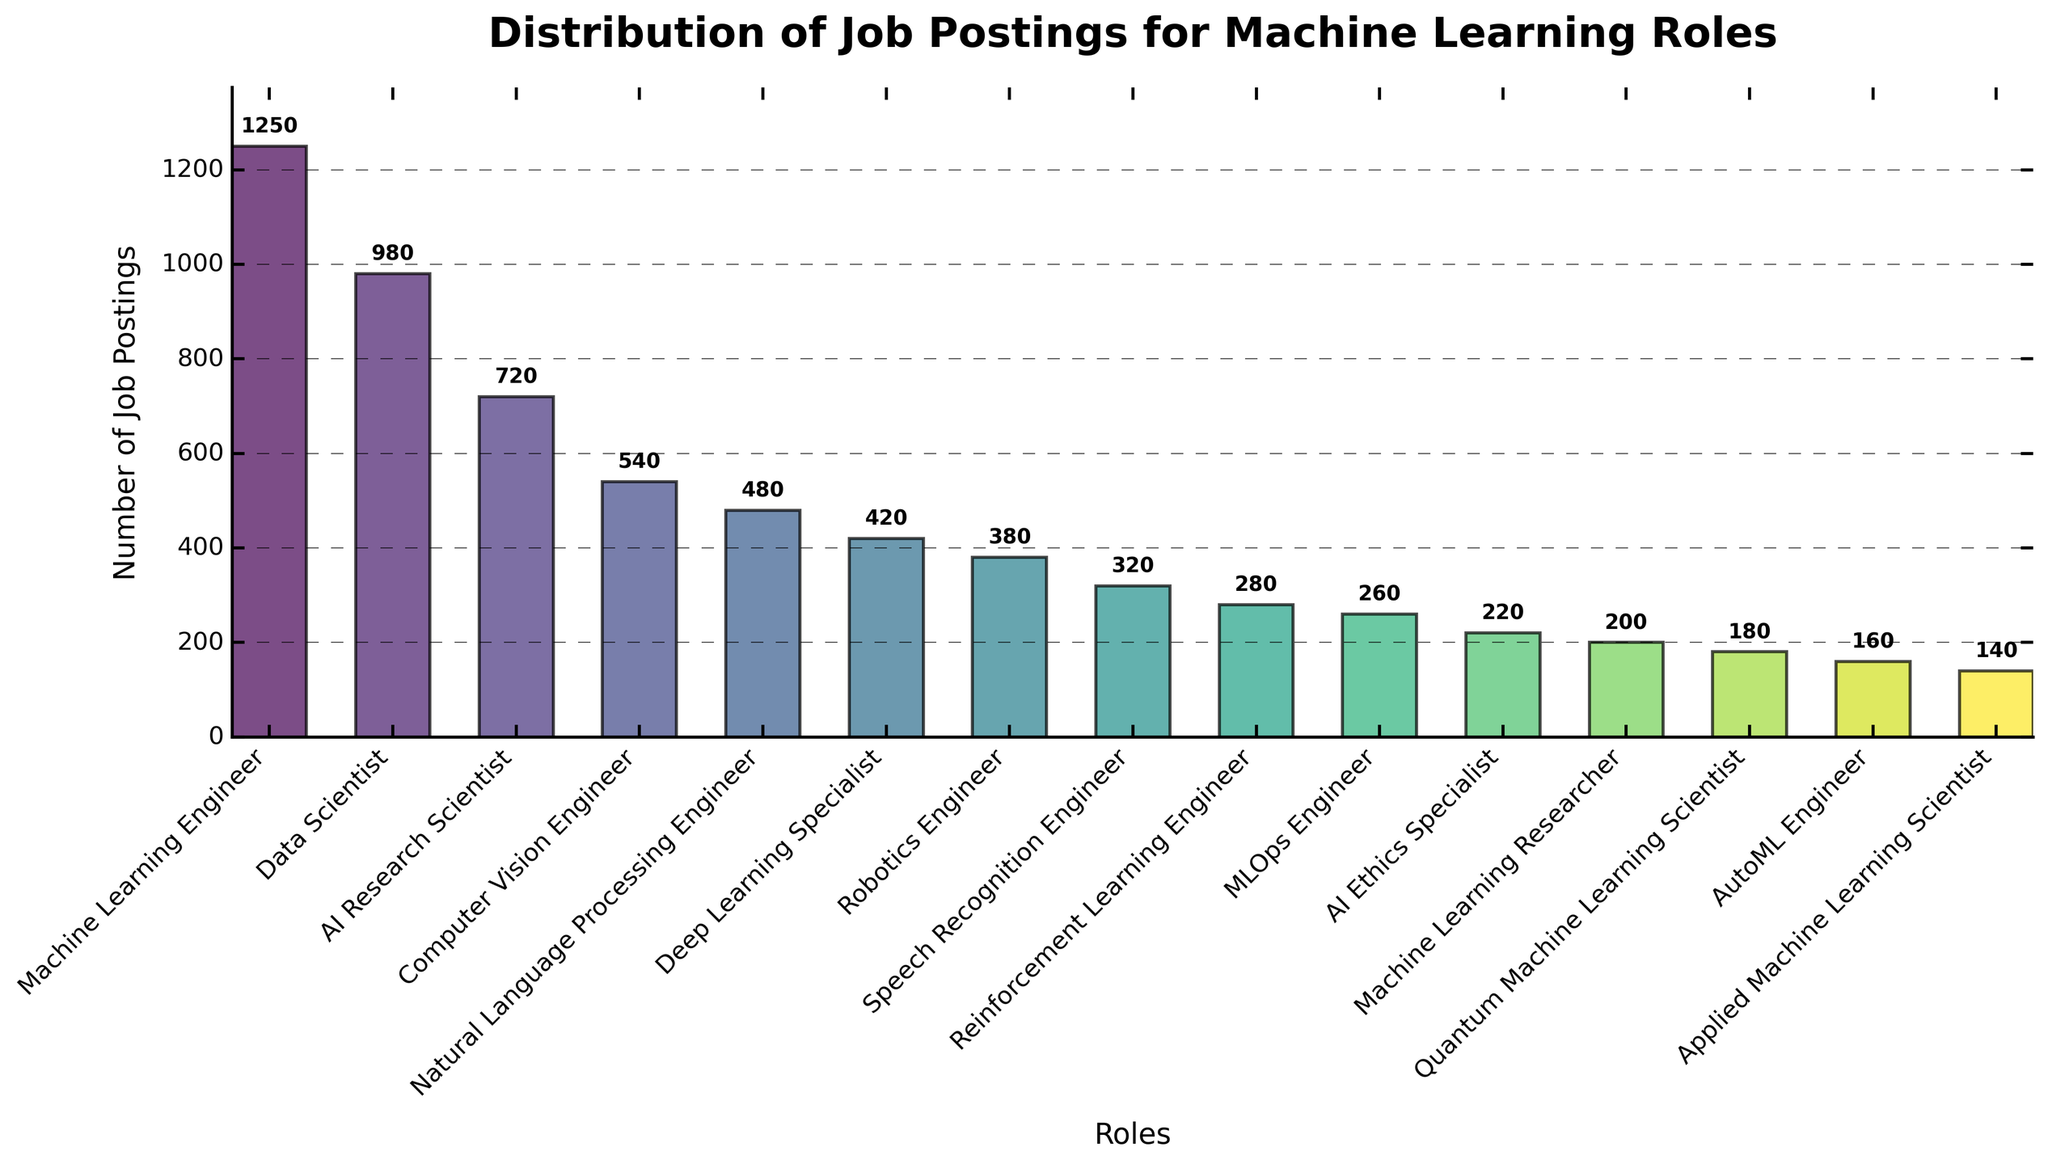How many more job postings are there for Machine Learning Engineers than for Data Scientists? To find the difference in the number of job postings between Machine Learning Engineers and Data Scientists, subtract the number of postings for Data Scientists from those for Machine Learning Engineers: 1250 - 980 = 270
Answer: 270 Which role has the fewest job postings, and how many postings does it have? By looking at the height of the bars, the role with the fewest job postings is Applied Machine Learning Scientist. Its bar is the shortest, representing 140 postings
Answer: Applied Machine Learning Scientist, 140 What's the combined total number of job postings for AI Research Scientist and Natural Language Processing Engineer roles? Add the number of job postings for both roles: 720 (AI Research Scientist) + 480 (Natural Language Processing Engineer) = 1200
Answer: 1200 Which role has fewer job postings: Deep Learning Specialist or MLOps Engineer? By comparing the heights of the bars for Deep Learning Specialist and MLOps Engineer roles, MLOps Engineer has fewer postings: 260 for MLOps Engineer vs. 420 for Deep Learning Specialist
Answer: MLOps Engineer What's the average number of job postings across all the roles? First, sum the number of job postings for all roles and then divide by the number of roles. The sum is 1250 + 980 + 720 + 540 + 480 + 420 + 380 + 320 + 280 + 260 + 220 + 200 + 180 + 160 + 140 = 7530. There are 15 roles, so the average is 7530 / 15 = 502
Answer: 502 Which role has a higher number of job postings, AI Ethics Specialist or Quantum Machine Learning Scientist, and by how much? Compare the heights of the bars for both roles. AI Ethics Specialist has 220 postings, and Quantum Machine Learning Scientist has 180 postings. The difference is 220 - 180 = 40
Answer: AI Ethics Specialist, by 40 What's the ratio of the number of job postings for Machine Learning Engineer to the number of postings for AutoML Engineer? To find the ratio, divide the number of postings for Machine Learning Engineer by the number for AutoML Engineer: 1250 / 160 = 7.8125
Answer: 7.8125 Identify the two roles with the highest number of job postings, and state their combined postings. The two roles with the highest number of job postings are Machine Learning Engineer (1250 postings) and Data Scientist (980 postings). Their combined postings are 1250 + 980 = 2230
Answer: Machine Learning Engineer and Data Scientist, 2230 How many more job postings are there for Communication roles (sum of Speech Recognition Engineer and Reinforcement Learning Engineer) compared to Robotics Engineer? First sum the number of postings for Speech Recognition Engineer and Reinforcement Learning Engineer: 320 + 280 = 600. Then subtract the number of postings for Robotics Engineer: 600 - 380 = 220
Answer: 220 